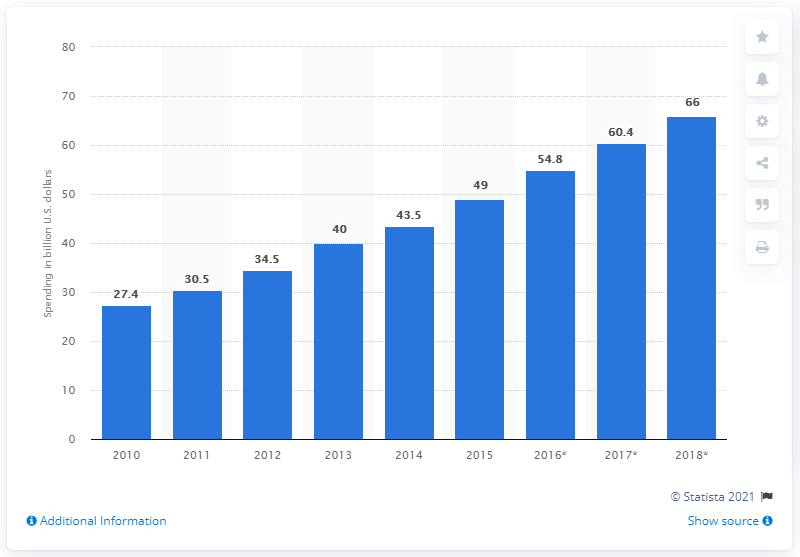Draw attention to some important aspects in this diagram. According to projections, global spending on cybersecurity reached $66 billion in 2018. 